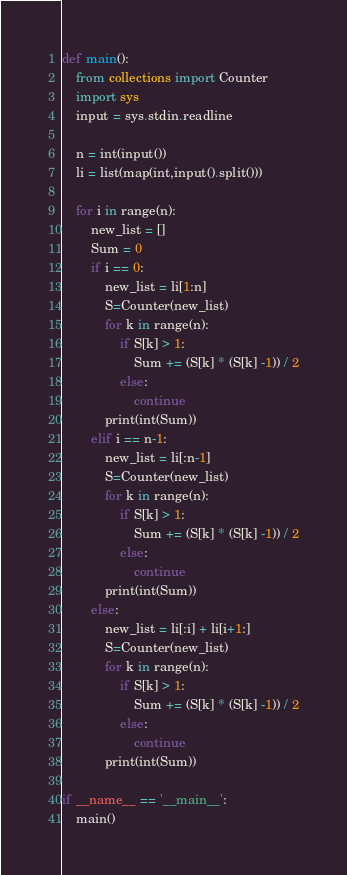<code> <loc_0><loc_0><loc_500><loc_500><_Python_>def main():
    from collections import Counter
    import sys
    input = sys.stdin.readline

    n = int(input())
    li = list(map(int,input().split()))

    for i in range(n):
        new_list = []
        Sum = 0
        if i == 0:
            new_list = li[1:n]
            S=Counter(new_list)
            for k in range(n):
                if S[k] > 1:
                    Sum += (S[k] * (S[k] -1)) / 2
                else:
                    continue
            print(int(Sum))
        elif i == n-1:
            new_list = li[:n-1]
            S=Counter(new_list)
            for k in range(n):
                if S[k] > 1:
                    Sum += (S[k] * (S[k] -1)) / 2
                else:
                    continue
            print(int(Sum))
        else:
            new_list = li[:i] + li[i+1:]
            S=Counter(new_list)
            for k in range(n):
                if S[k] > 1:
                    Sum += (S[k] * (S[k] -1)) / 2
                else:
                    continue
            print(int(Sum))

if __name__ == '__main__':
    main()</code> 